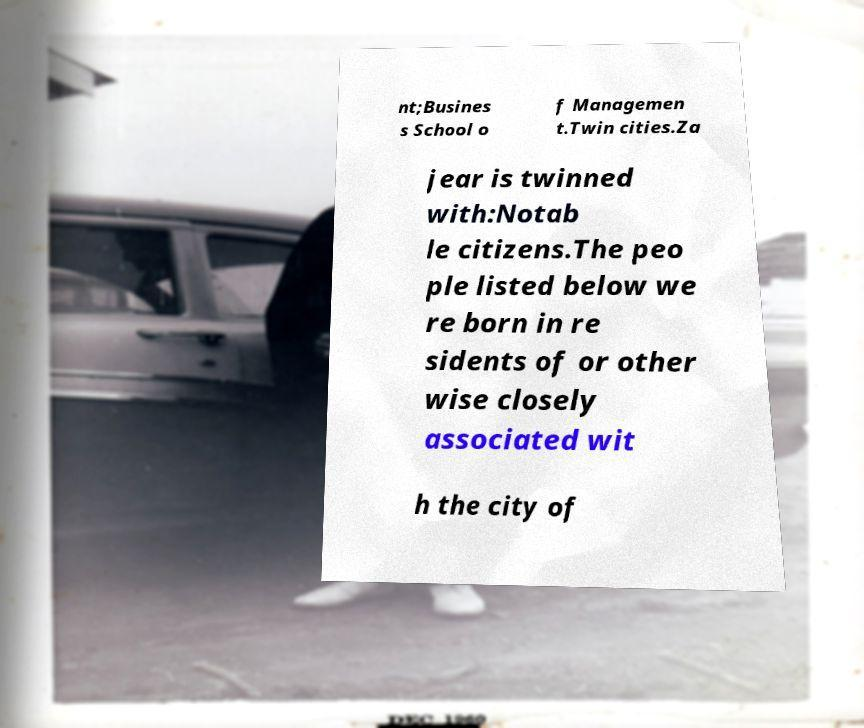Please identify and transcribe the text found in this image. nt;Busines s School o f Managemen t.Twin cities.Za jear is twinned with:Notab le citizens.The peo ple listed below we re born in re sidents of or other wise closely associated wit h the city of 